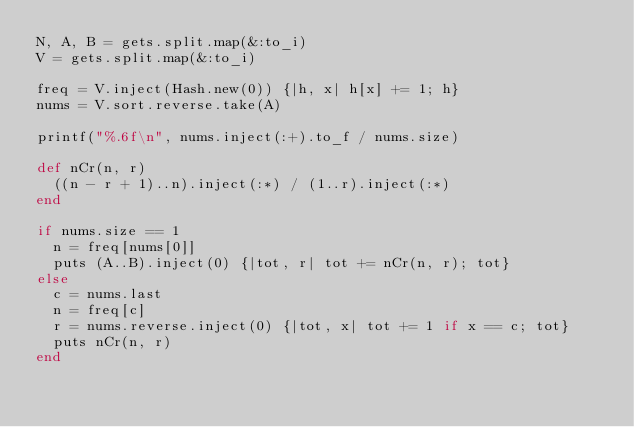<code> <loc_0><loc_0><loc_500><loc_500><_Ruby_>N, A, B = gets.split.map(&:to_i)
V = gets.split.map(&:to_i)

freq = V.inject(Hash.new(0)) {|h, x| h[x] += 1; h}
nums = V.sort.reverse.take(A)

printf("%.6f\n", nums.inject(:+).to_f / nums.size)

def nCr(n, r)
  ((n - r + 1)..n).inject(:*) / (1..r).inject(:*)
end

if nums.size == 1 
  n = freq[nums[0]]
  puts (A..B).inject(0) {|tot, r| tot += nCr(n, r); tot}
else
  c = nums.last
  n = freq[c]
  r = nums.reverse.inject(0) {|tot, x| tot += 1 if x == c; tot}
  puts nCr(n, r)
end</code> 